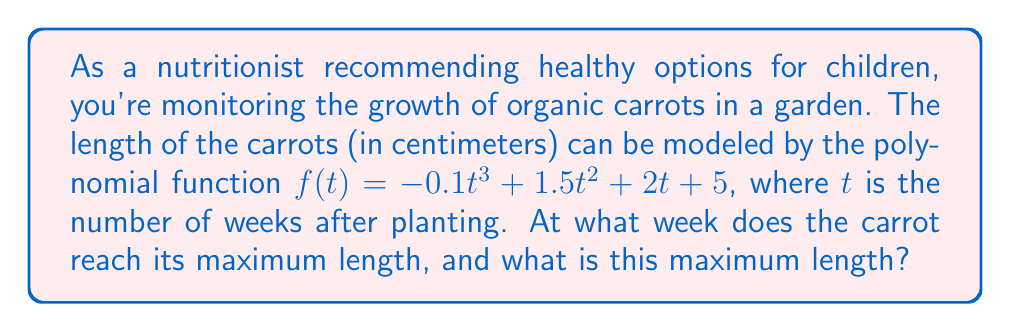Can you solve this math problem? To find the maximum length of the carrot and when it occurs, we need to follow these steps:

1) The maximum length will occur at the highest point of the polynomial function. This point can be found by determining where the derivative of the function equals zero.

2) Let's find the derivative of $f(t)$:
   $f'(t) = -0.3t^2 + 3t + 2$

3) Set the derivative equal to zero and solve for $t$:
   $-0.3t^2 + 3t + 2 = 0$

4) This is a quadratic equation. We can solve it using the quadratic formula:
   $t = \frac{-b \pm \sqrt{b^2 - 4ac}}{2a}$

   Where $a = -0.3$, $b = 3$, and $c = 2$

5) Plugging in these values:
   $t = \frac{-3 \pm \sqrt{3^2 - 4(-0.3)(2)}}{2(-0.3)}$
   $= \frac{-3 \pm \sqrt{9 + 2.4}}{-0.6}$
   $= \frac{-3 \pm \sqrt{11.4}}{-0.6}$
   $= \frac{-3 \pm 3.37}{-0.6}$

6) This gives us two solutions:
   $t_1 = \frac{-3 + 3.37}{-0.6} \approx 0.62$
   $t_2 = \frac{-3 - 3.37}{-0.6} \approx 10.62$

7) The second solution, 10.62 weeks, is the one we're interested in as it represents the maximum point.

8) To find the maximum length, we plug this value of $t$ back into our original function:
   $f(10.62) = -0.1(10.62)^3 + 1.5(10.62)^2 + 2(10.62) + 5$
   $\approx 38.76$ cm

Therefore, the carrot reaches its maximum length of approximately 38.76 cm at about 10.62 weeks after planting.
Answer: 10.62 weeks; 38.76 cm 